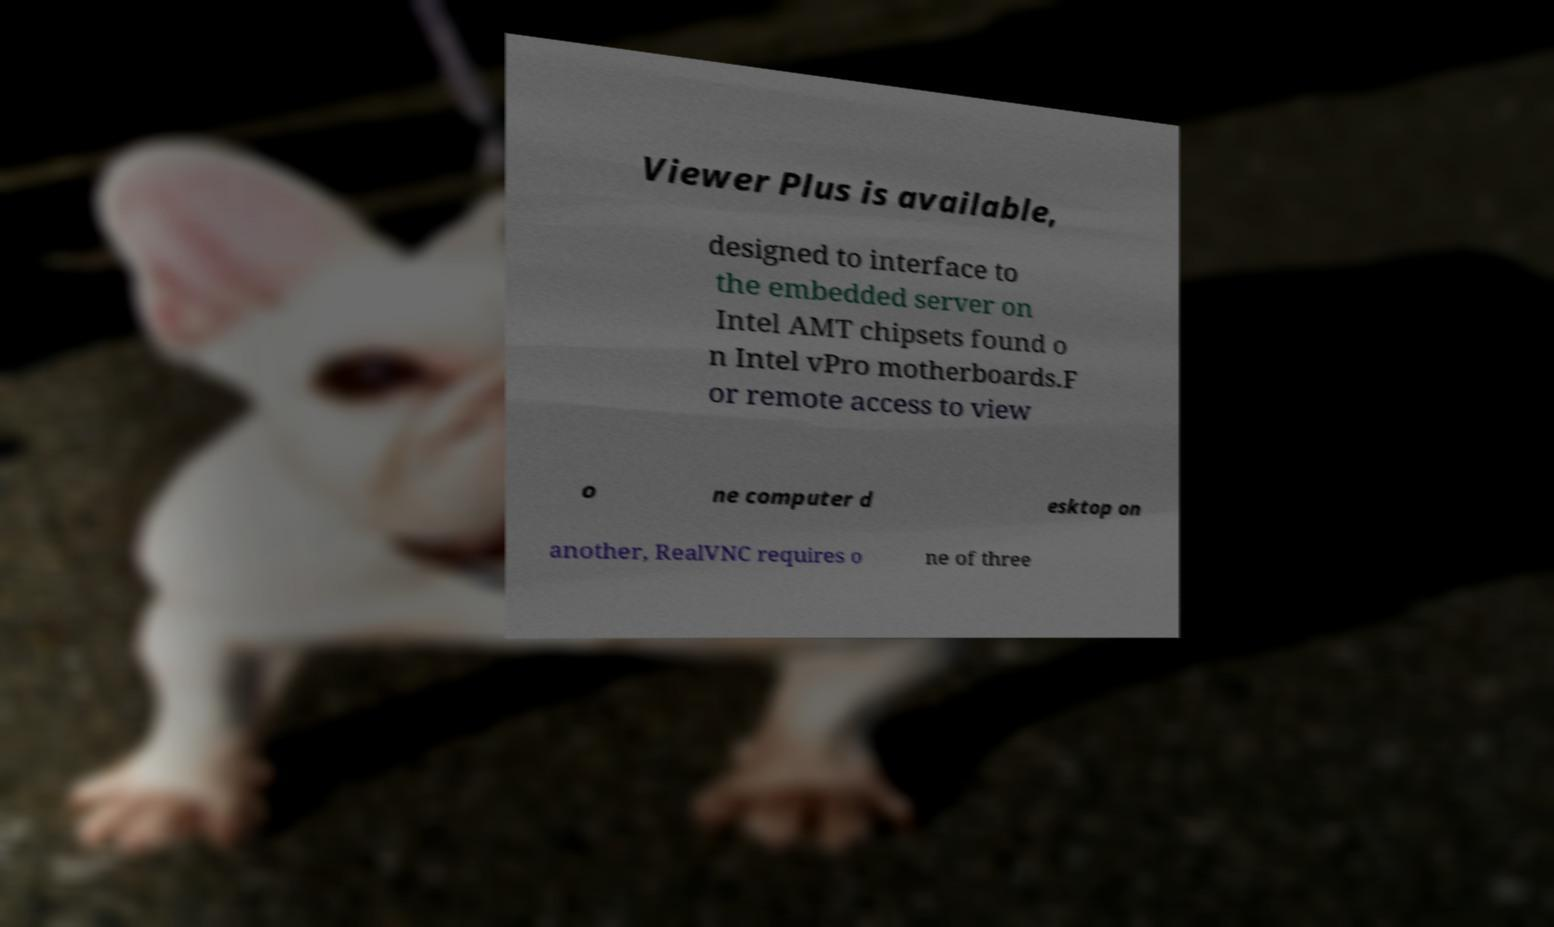Can you accurately transcribe the text from the provided image for me? Viewer Plus is available, designed to interface to the embedded server on Intel AMT chipsets found o n Intel vPro motherboards.F or remote access to view o ne computer d esktop on another, RealVNC requires o ne of three 